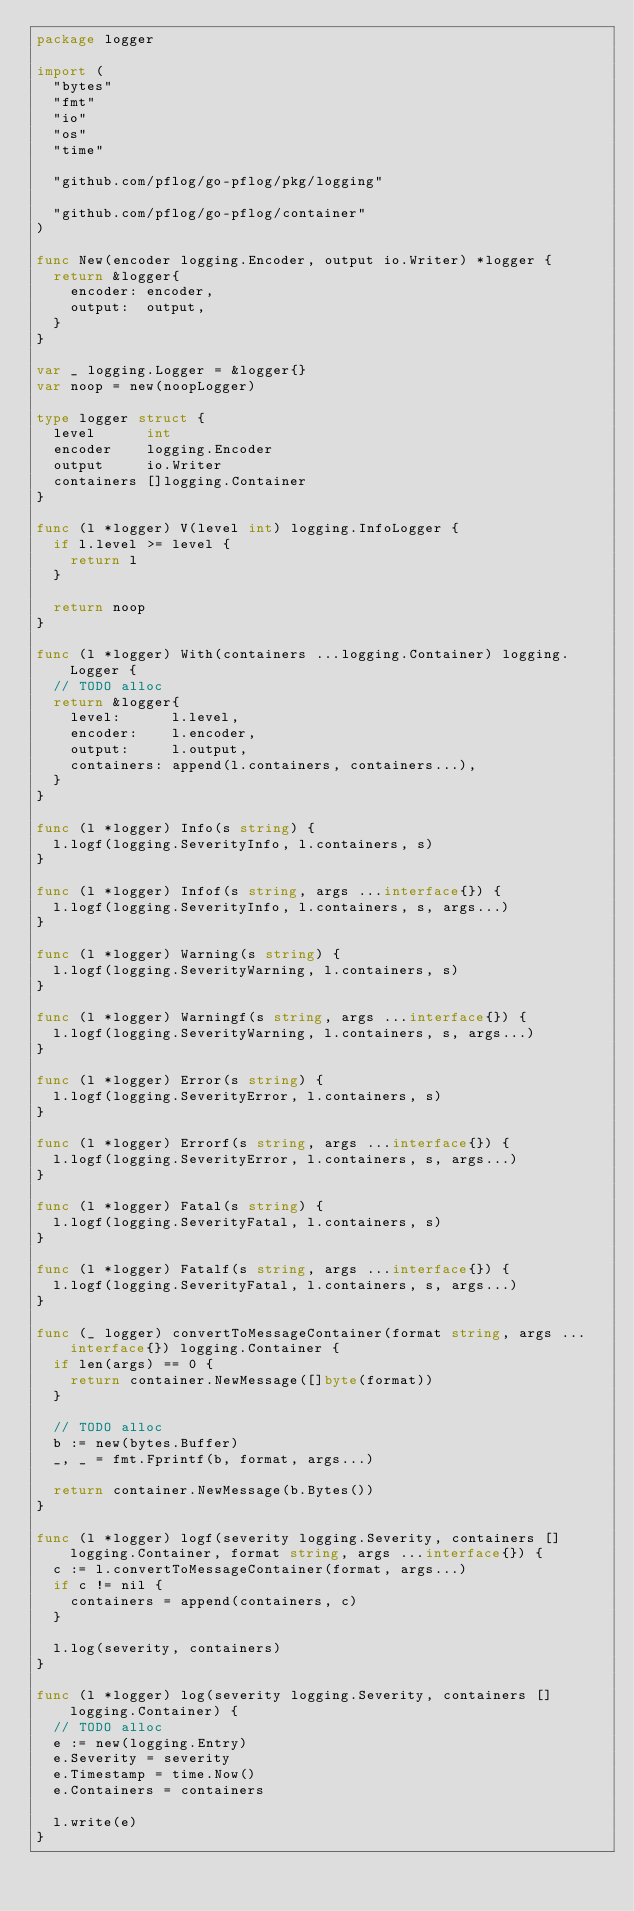Convert code to text. <code><loc_0><loc_0><loc_500><loc_500><_Go_>package logger

import (
	"bytes"
	"fmt"
	"io"
	"os"
	"time"

	"github.com/pflog/go-pflog/pkg/logging"

	"github.com/pflog/go-pflog/container"
)

func New(encoder logging.Encoder, output io.Writer) *logger {
	return &logger{
		encoder: encoder,
		output:  output,
	}
}

var _ logging.Logger = &logger{}
var noop = new(noopLogger)

type logger struct {
	level      int
	encoder    logging.Encoder
	output     io.Writer
	containers []logging.Container
}

func (l *logger) V(level int) logging.InfoLogger {
	if l.level >= level {
		return l
	}

	return noop
}

func (l *logger) With(containers ...logging.Container) logging.Logger {
	// TODO alloc
	return &logger{
		level:      l.level,
		encoder:    l.encoder,
		output:     l.output,
		containers: append(l.containers, containers...),
	}
}

func (l *logger) Info(s string) {
	l.logf(logging.SeverityInfo, l.containers, s)
}

func (l *logger) Infof(s string, args ...interface{}) {
	l.logf(logging.SeverityInfo, l.containers, s, args...)
}

func (l *logger) Warning(s string) {
	l.logf(logging.SeverityWarning, l.containers, s)
}

func (l *logger) Warningf(s string, args ...interface{}) {
	l.logf(logging.SeverityWarning, l.containers, s, args...)
}

func (l *logger) Error(s string) {
	l.logf(logging.SeverityError, l.containers, s)
}

func (l *logger) Errorf(s string, args ...interface{}) {
	l.logf(logging.SeverityError, l.containers, s, args...)
}

func (l *logger) Fatal(s string) {
	l.logf(logging.SeverityFatal, l.containers, s)
}

func (l *logger) Fatalf(s string, args ...interface{}) {
	l.logf(logging.SeverityFatal, l.containers, s, args...)
}

func (_ logger) convertToMessageContainer(format string, args ...interface{}) logging.Container {
	if len(args) == 0 {
		return container.NewMessage([]byte(format))
	}

	// TODO alloc
	b := new(bytes.Buffer)
	_, _ = fmt.Fprintf(b, format, args...)

	return container.NewMessage(b.Bytes())
}

func (l *logger) logf(severity logging.Severity, containers []logging.Container, format string, args ...interface{}) {
	c := l.convertToMessageContainer(format, args...)
	if c != nil {
		containers = append(containers, c)
	}

	l.log(severity, containers)
}

func (l *logger) log(severity logging.Severity, containers []logging.Container) {
	// TODO alloc
	e := new(logging.Entry)
	e.Severity = severity
	e.Timestamp = time.Now()
	e.Containers = containers

	l.write(e)
}
</code> 